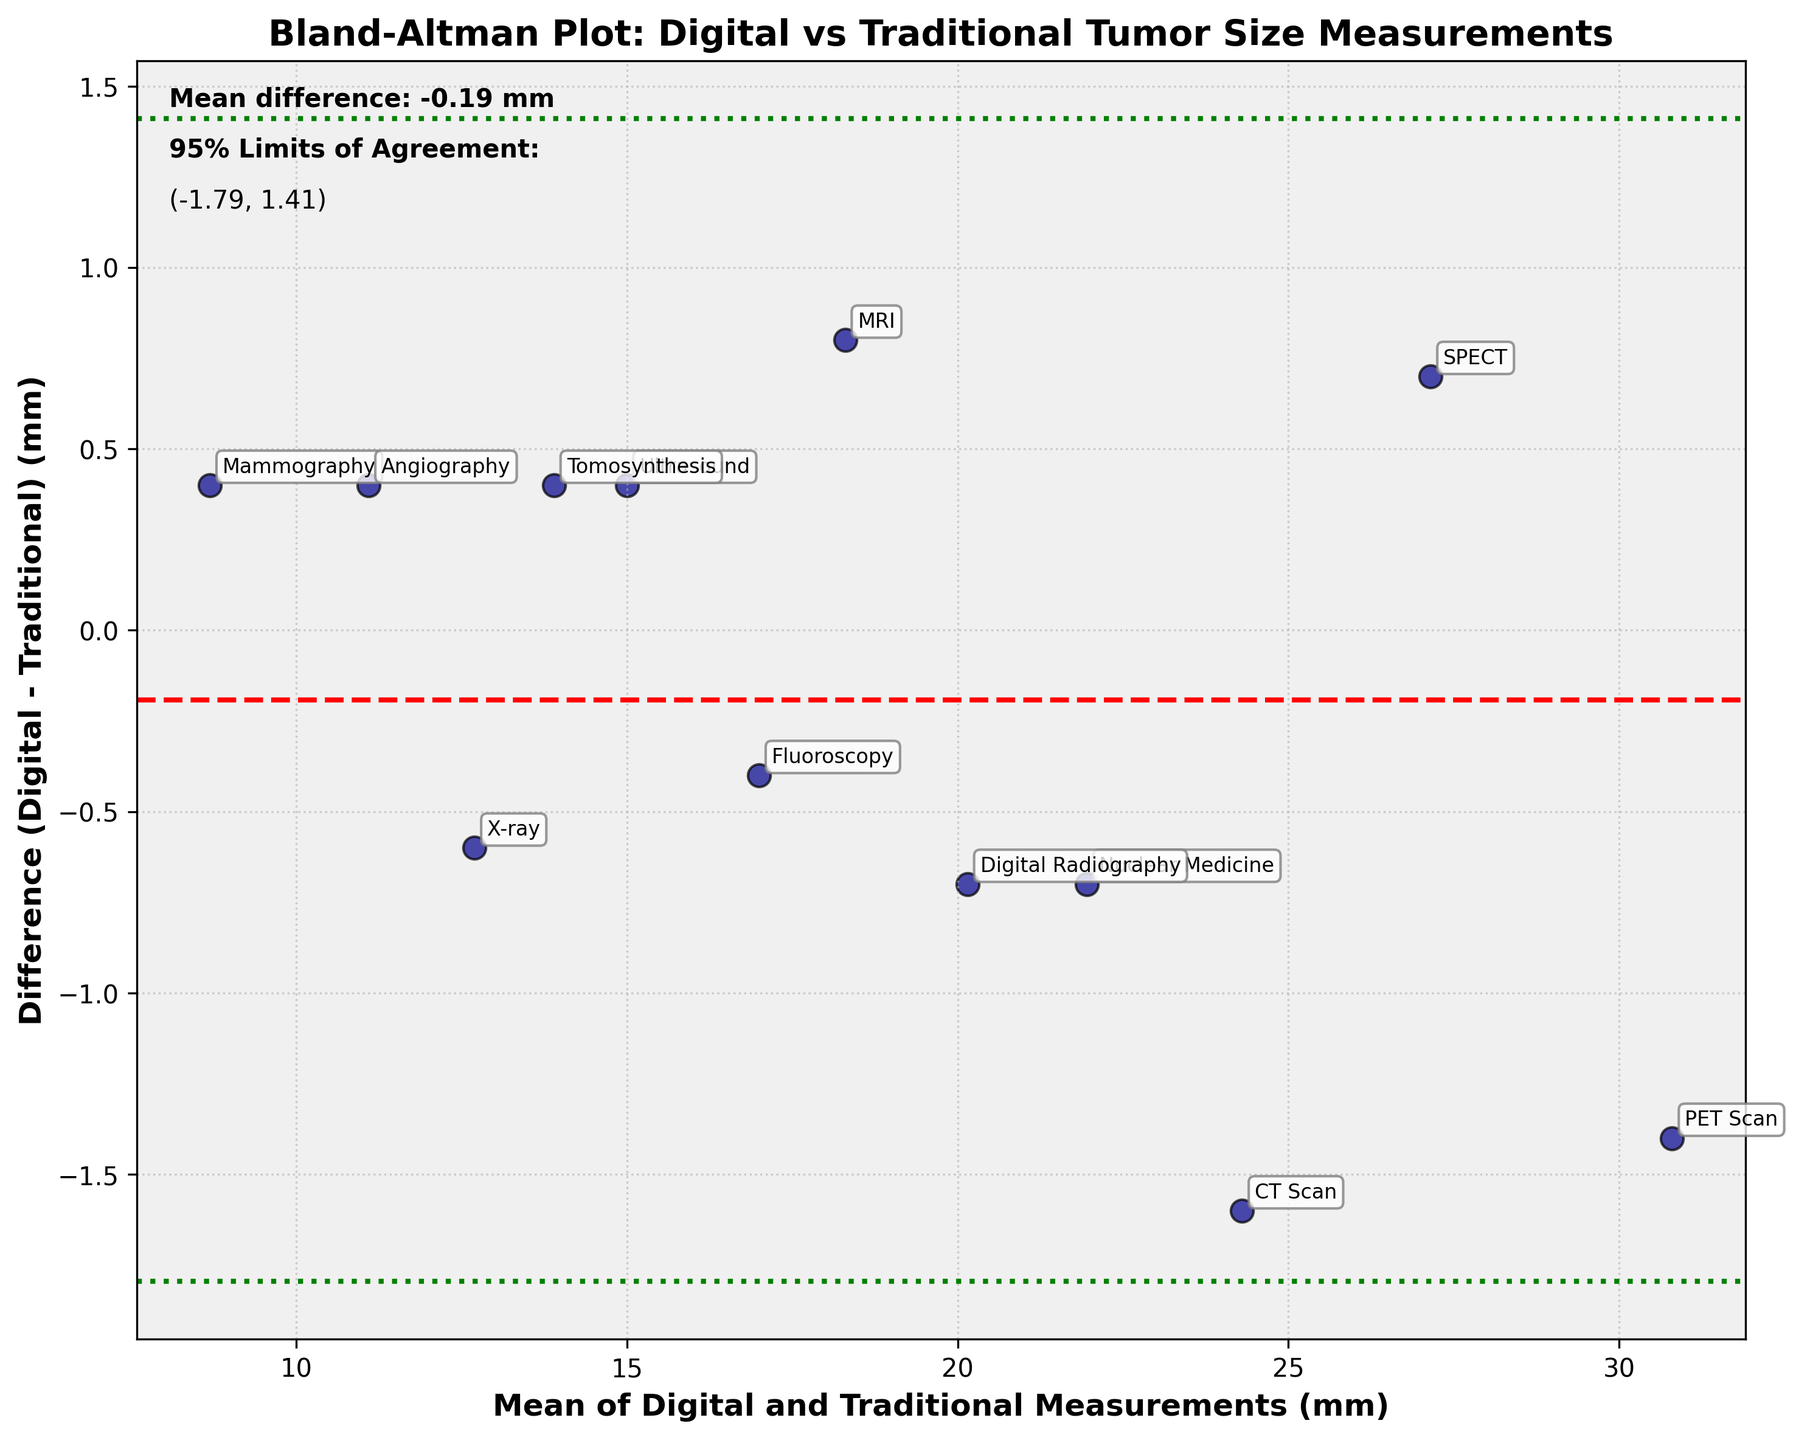What is the title of the plot? The title of the plot is written at the top and reads "Bland-Altman Plot: Digital vs Traditional Tumor Size Measurements"
Answer: Bland-Altman Plot: Digital vs Traditional Tumor Size Measurements What do the green dotted lines represent? The green dotted lines represent the 95% limits of agreement
Answer: 95% limits of agreement How many methods are compared in the plot? The plot has annotated points for each method, count the number of methods labeled: CT Scan, MRI, Ultrasound, PET Scan, X-ray, Mammography, Nuclear Medicine, Fluoroscopy, Angiography, SPECT, Digital Radiography, Tomosynthesis. There are 12 methods
Answer: 12 What does the red dashed line indicate? The red dashed line represents the mean difference between the digital and traditional measurements
Answer: Mean difference Which method shows the largest positive difference between digital and traditional measurements? By observing the positions of the points relative to the vertical (difference) axis, the method closest to the top is PET Scan, indicating the largest positive difference
Answer: PET Scan Which method has the closest agreement with the smallest difference? Look for the data point closest to the horizontal mean difference line (red dashed line) at the center, it is Mammography
Answer: Mammography What is the approximate mean difference value indicated in the plot? The mean difference is labeled with accompanying text on the chart itself, close to the red dashed line. It is about 0.21 mm
Answer: 0.21 mm What is the range of the 95% Limits of Agreement? The range of the 95% Limits of Agreement is labeled on the plot with green dotted lines and accompanying text. The values are approximately (−2.34 mm, 2.77 mm)
Answer: (−2.34 mm, 2.77 mm) Which method falls just above the lower limit of agreement? Look for the data point that is closest and just above the lower green dotted line on the plot. It is X-ray
Answer: X-ray What does each point on this plot represent? Each point on the plot represents a single method's average measurement (mean of digital and traditional) on the x-axis and the difference between the two measurements on the y-axis
Answer: A single method's measurements 